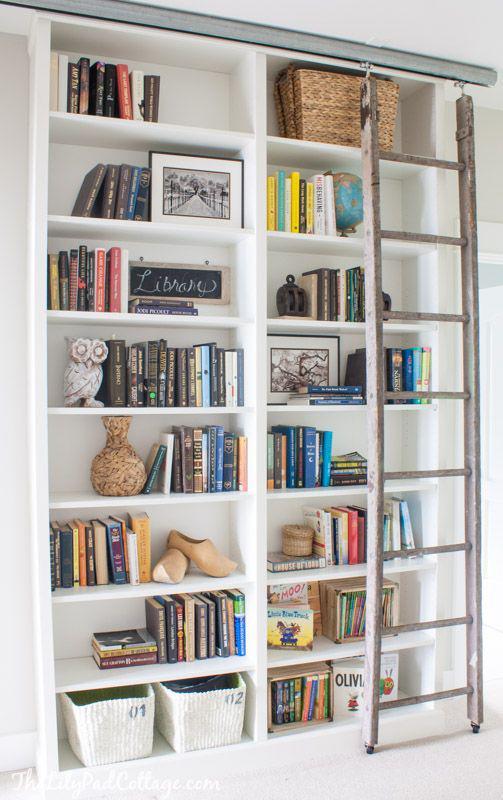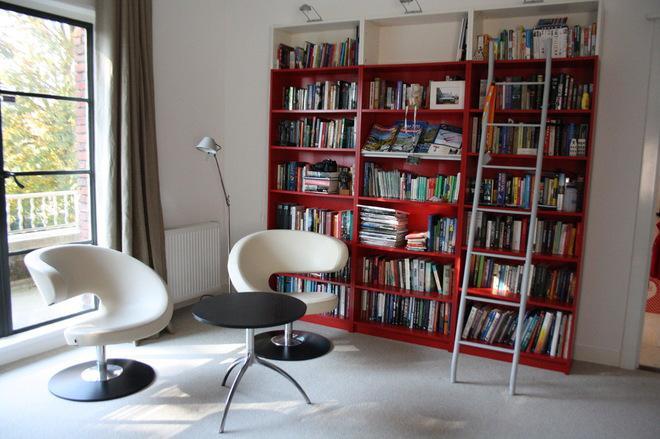The first image is the image on the left, the second image is the image on the right. Considering the images on both sides, is "A chair is near a book shelf." valid? Answer yes or no. Yes. The first image is the image on the left, the second image is the image on the right. For the images shown, is this caption "Seating furniture is visible in front of a bookcase in one image." true? Answer yes or no. Yes. 